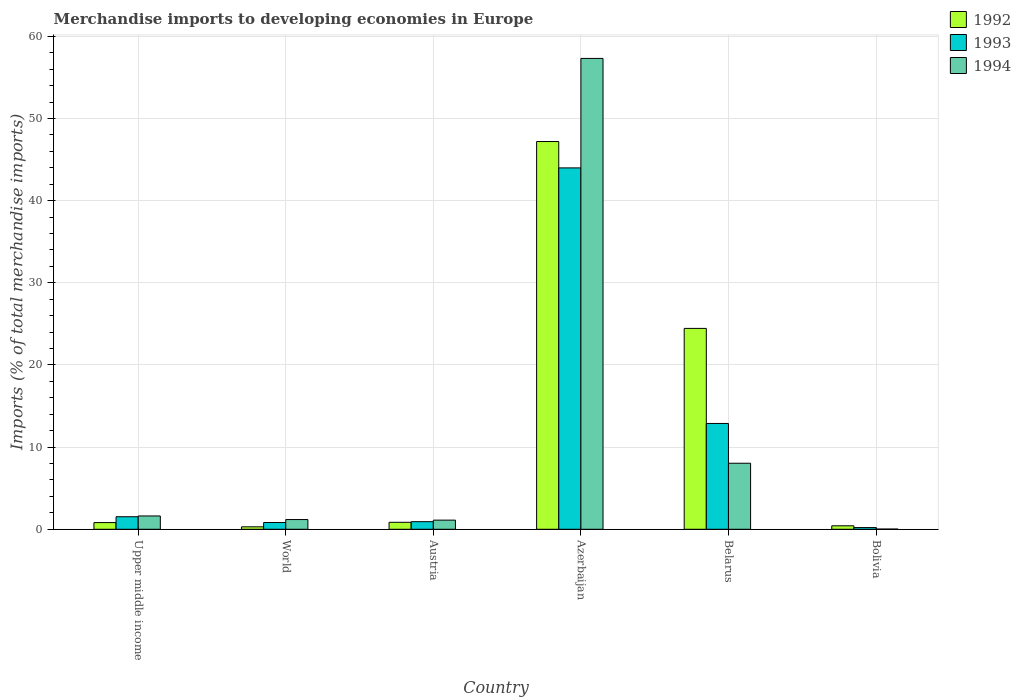How many different coloured bars are there?
Your response must be concise. 3. How many groups of bars are there?
Make the answer very short. 6. Are the number of bars per tick equal to the number of legend labels?
Keep it short and to the point. Yes. How many bars are there on the 6th tick from the left?
Offer a very short reply. 3. How many bars are there on the 1st tick from the right?
Provide a short and direct response. 3. What is the label of the 4th group of bars from the left?
Your response must be concise. Azerbaijan. In how many cases, is the number of bars for a given country not equal to the number of legend labels?
Your answer should be compact. 0. What is the percentage total merchandise imports in 1993 in Austria?
Ensure brevity in your answer.  0.93. Across all countries, what is the maximum percentage total merchandise imports in 1992?
Provide a succinct answer. 47.2. Across all countries, what is the minimum percentage total merchandise imports in 1994?
Make the answer very short. 0.02. In which country was the percentage total merchandise imports in 1993 maximum?
Ensure brevity in your answer.  Azerbaijan. What is the total percentage total merchandise imports in 1994 in the graph?
Your response must be concise. 69.29. What is the difference between the percentage total merchandise imports in 1993 in Austria and that in Belarus?
Keep it short and to the point. -11.95. What is the difference between the percentage total merchandise imports in 1992 in Upper middle income and the percentage total merchandise imports in 1993 in World?
Your answer should be very brief. -0.01. What is the average percentage total merchandise imports in 1994 per country?
Provide a short and direct response. 11.55. What is the difference between the percentage total merchandise imports of/in 1992 and percentage total merchandise imports of/in 1993 in Belarus?
Ensure brevity in your answer.  11.57. In how many countries, is the percentage total merchandise imports in 1993 greater than 58 %?
Offer a very short reply. 0. What is the ratio of the percentage total merchandise imports in 1993 in Belarus to that in World?
Ensure brevity in your answer.  15.63. Is the percentage total merchandise imports in 1993 in Austria less than that in World?
Your answer should be compact. No. Is the difference between the percentage total merchandise imports in 1992 in Azerbaijan and Bolivia greater than the difference between the percentage total merchandise imports in 1993 in Azerbaijan and Bolivia?
Keep it short and to the point. Yes. What is the difference between the highest and the second highest percentage total merchandise imports in 1993?
Give a very brief answer. -42.46. What is the difference between the highest and the lowest percentage total merchandise imports in 1994?
Offer a very short reply. 57.29. Is the sum of the percentage total merchandise imports in 1993 in Austria and Upper middle income greater than the maximum percentage total merchandise imports in 1992 across all countries?
Ensure brevity in your answer.  No. Are all the bars in the graph horizontal?
Give a very brief answer. No. How many countries are there in the graph?
Offer a very short reply. 6. Are the values on the major ticks of Y-axis written in scientific E-notation?
Offer a terse response. No. Where does the legend appear in the graph?
Offer a terse response. Top right. How are the legend labels stacked?
Your answer should be very brief. Vertical. What is the title of the graph?
Keep it short and to the point. Merchandise imports to developing economies in Europe. Does "1993" appear as one of the legend labels in the graph?
Provide a short and direct response. Yes. What is the label or title of the Y-axis?
Your answer should be compact. Imports (% of total merchandise imports). What is the Imports (% of total merchandise imports) of 1992 in Upper middle income?
Make the answer very short. 0.81. What is the Imports (% of total merchandise imports) of 1993 in Upper middle income?
Keep it short and to the point. 1.53. What is the Imports (% of total merchandise imports) of 1994 in Upper middle income?
Keep it short and to the point. 1.62. What is the Imports (% of total merchandise imports) of 1992 in World?
Ensure brevity in your answer.  0.3. What is the Imports (% of total merchandise imports) in 1993 in World?
Provide a succinct answer. 0.82. What is the Imports (% of total merchandise imports) of 1994 in World?
Offer a terse response. 1.18. What is the Imports (% of total merchandise imports) in 1992 in Austria?
Your answer should be very brief. 0.85. What is the Imports (% of total merchandise imports) in 1993 in Austria?
Provide a short and direct response. 0.93. What is the Imports (% of total merchandise imports) in 1994 in Austria?
Keep it short and to the point. 1.11. What is the Imports (% of total merchandise imports) in 1992 in Azerbaijan?
Your answer should be very brief. 47.2. What is the Imports (% of total merchandise imports) of 1993 in Azerbaijan?
Ensure brevity in your answer.  43.99. What is the Imports (% of total merchandise imports) of 1994 in Azerbaijan?
Your answer should be compact. 57.31. What is the Imports (% of total merchandise imports) of 1992 in Belarus?
Offer a very short reply. 24.45. What is the Imports (% of total merchandise imports) in 1993 in Belarus?
Keep it short and to the point. 12.88. What is the Imports (% of total merchandise imports) in 1994 in Belarus?
Keep it short and to the point. 8.04. What is the Imports (% of total merchandise imports) in 1992 in Bolivia?
Provide a succinct answer. 0.42. What is the Imports (% of total merchandise imports) of 1993 in Bolivia?
Give a very brief answer. 0.21. What is the Imports (% of total merchandise imports) of 1994 in Bolivia?
Your answer should be very brief. 0.02. Across all countries, what is the maximum Imports (% of total merchandise imports) in 1992?
Make the answer very short. 47.2. Across all countries, what is the maximum Imports (% of total merchandise imports) in 1993?
Provide a succinct answer. 43.99. Across all countries, what is the maximum Imports (% of total merchandise imports) of 1994?
Your response must be concise. 57.31. Across all countries, what is the minimum Imports (% of total merchandise imports) of 1992?
Keep it short and to the point. 0.3. Across all countries, what is the minimum Imports (% of total merchandise imports) in 1993?
Keep it short and to the point. 0.21. Across all countries, what is the minimum Imports (% of total merchandise imports) of 1994?
Your answer should be compact. 0.02. What is the total Imports (% of total merchandise imports) in 1992 in the graph?
Provide a succinct answer. 74.03. What is the total Imports (% of total merchandise imports) in 1993 in the graph?
Give a very brief answer. 60.35. What is the total Imports (% of total merchandise imports) in 1994 in the graph?
Give a very brief answer. 69.29. What is the difference between the Imports (% of total merchandise imports) in 1992 in Upper middle income and that in World?
Your answer should be compact. 0.52. What is the difference between the Imports (% of total merchandise imports) in 1993 in Upper middle income and that in World?
Your answer should be very brief. 0.7. What is the difference between the Imports (% of total merchandise imports) in 1994 in Upper middle income and that in World?
Keep it short and to the point. 0.44. What is the difference between the Imports (% of total merchandise imports) in 1992 in Upper middle income and that in Austria?
Make the answer very short. -0.03. What is the difference between the Imports (% of total merchandise imports) of 1993 in Upper middle income and that in Austria?
Provide a short and direct response. 0.6. What is the difference between the Imports (% of total merchandise imports) in 1994 in Upper middle income and that in Austria?
Your answer should be very brief. 0.51. What is the difference between the Imports (% of total merchandise imports) in 1992 in Upper middle income and that in Azerbaijan?
Make the answer very short. -46.38. What is the difference between the Imports (% of total merchandise imports) in 1993 in Upper middle income and that in Azerbaijan?
Provide a short and direct response. -42.46. What is the difference between the Imports (% of total merchandise imports) in 1994 in Upper middle income and that in Azerbaijan?
Ensure brevity in your answer.  -55.69. What is the difference between the Imports (% of total merchandise imports) of 1992 in Upper middle income and that in Belarus?
Offer a very short reply. -23.64. What is the difference between the Imports (% of total merchandise imports) of 1993 in Upper middle income and that in Belarus?
Offer a terse response. -11.35. What is the difference between the Imports (% of total merchandise imports) in 1994 in Upper middle income and that in Belarus?
Your response must be concise. -6.42. What is the difference between the Imports (% of total merchandise imports) of 1992 in Upper middle income and that in Bolivia?
Offer a very short reply. 0.39. What is the difference between the Imports (% of total merchandise imports) in 1993 in Upper middle income and that in Bolivia?
Provide a short and direct response. 1.32. What is the difference between the Imports (% of total merchandise imports) in 1994 in Upper middle income and that in Bolivia?
Provide a short and direct response. 1.6. What is the difference between the Imports (% of total merchandise imports) in 1992 in World and that in Austria?
Your answer should be compact. -0.55. What is the difference between the Imports (% of total merchandise imports) in 1993 in World and that in Austria?
Your answer should be compact. -0.1. What is the difference between the Imports (% of total merchandise imports) of 1994 in World and that in Austria?
Offer a very short reply. 0.07. What is the difference between the Imports (% of total merchandise imports) in 1992 in World and that in Azerbaijan?
Offer a very short reply. -46.9. What is the difference between the Imports (% of total merchandise imports) in 1993 in World and that in Azerbaijan?
Your answer should be compact. -43.16. What is the difference between the Imports (% of total merchandise imports) in 1994 in World and that in Azerbaijan?
Ensure brevity in your answer.  -56.13. What is the difference between the Imports (% of total merchandise imports) in 1992 in World and that in Belarus?
Offer a very short reply. -24.15. What is the difference between the Imports (% of total merchandise imports) of 1993 in World and that in Belarus?
Ensure brevity in your answer.  -12.06. What is the difference between the Imports (% of total merchandise imports) in 1994 in World and that in Belarus?
Provide a succinct answer. -6.85. What is the difference between the Imports (% of total merchandise imports) of 1992 in World and that in Bolivia?
Your answer should be very brief. -0.12. What is the difference between the Imports (% of total merchandise imports) in 1993 in World and that in Bolivia?
Make the answer very short. 0.62. What is the difference between the Imports (% of total merchandise imports) in 1994 in World and that in Bolivia?
Keep it short and to the point. 1.16. What is the difference between the Imports (% of total merchandise imports) of 1992 in Austria and that in Azerbaijan?
Your answer should be very brief. -46.35. What is the difference between the Imports (% of total merchandise imports) in 1993 in Austria and that in Azerbaijan?
Offer a terse response. -43.06. What is the difference between the Imports (% of total merchandise imports) of 1994 in Austria and that in Azerbaijan?
Provide a short and direct response. -56.2. What is the difference between the Imports (% of total merchandise imports) of 1992 in Austria and that in Belarus?
Ensure brevity in your answer.  -23.6. What is the difference between the Imports (% of total merchandise imports) of 1993 in Austria and that in Belarus?
Ensure brevity in your answer.  -11.95. What is the difference between the Imports (% of total merchandise imports) in 1994 in Austria and that in Belarus?
Your response must be concise. -6.92. What is the difference between the Imports (% of total merchandise imports) in 1992 in Austria and that in Bolivia?
Offer a terse response. 0.43. What is the difference between the Imports (% of total merchandise imports) in 1993 in Austria and that in Bolivia?
Keep it short and to the point. 0.72. What is the difference between the Imports (% of total merchandise imports) in 1994 in Austria and that in Bolivia?
Provide a short and direct response. 1.09. What is the difference between the Imports (% of total merchandise imports) in 1992 in Azerbaijan and that in Belarus?
Your answer should be very brief. 22.75. What is the difference between the Imports (% of total merchandise imports) in 1993 in Azerbaijan and that in Belarus?
Give a very brief answer. 31.11. What is the difference between the Imports (% of total merchandise imports) in 1994 in Azerbaijan and that in Belarus?
Your response must be concise. 49.28. What is the difference between the Imports (% of total merchandise imports) in 1992 in Azerbaijan and that in Bolivia?
Your response must be concise. 46.78. What is the difference between the Imports (% of total merchandise imports) of 1993 in Azerbaijan and that in Bolivia?
Provide a succinct answer. 43.78. What is the difference between the Imports (% of total merchandise imports) of 1994 in Azerbaijan and that in Bolivia?
Give a very brief answer. 57.29. What is the difference between the Imports (% of total merchandise imports) of 1992 in Belarus and that in Bolivia?
Provide a short and direct response. 24.03. What is the difference between the Imports (% of total merchandise imports) of 1993 in Belarus and that in Bolivia?
Make the answer very short. 12.67. What is the difference between the Imports (% of total merchandise imports) in 1994 in Belarus and that in Bolivia?
Give a very brief answer. 8.01. What is the difference between the Imports (% of total merchandise imports) of 1992 in Upper middle income and the Imports (% of total merchandise imports) of 1993 in World?
Make the answer very short. -0.01. What is the difference between the Imports (% of total merchandise imports) in 1992 in Upper middle income and the Imports (% of total merchandise imports) in 1994 in World?
Offer a terse response. -0.37. What is the difference between the Imports (% of total merchandise imports) in 1993 in Upper middle income and the Imports (% of total merchandise imports) in 1994 in World?
Offer a very short reply. 0.34. What is the difference between the Imports (% of total merchandise imports) in 1992 in Upper middle income and the Imports (% of total merchandise imports) in 1993 in Austria?
Your answer should be compact. -0.11. What is the difference between the Imports (% of total merchandise imports) of 1992 in Upper middle income and the Imports (% of total merchandise imports) of 1994 in Austria?
Provide a succinct answer. -0.3. What is the difference between the Imports (% of total merchandise imports) in 1993 in Upper middle income and the Imports (% of total merchandise imports) in 1994 in Austria?
Provide a succinct answer. 0.41. What is the difference between the Imports (% of total merchandise imports) in 1992 in Upper middle income and the Imports (% of total merchandise imports) in 1993 in Azerbaijan?
Ensure brevity in your answer.  -43.17. What is the difference between the Imports (% of total merchandise imports) in 1992 in Upper middle income and the Imports (% of total merchandise imports) in 1994 in Azerbaijan?
Keep it short and to the point. -56.5. What is the difference between the Imports (% of total merchandise imports) of 1993 in Upper middle income and the Imports (% of total merchandise imports) of 1994 in Azerbaijan?
Offer a terse response. -55.79. What is the difference between the Imports (% of total merchandise imports) in 1992 in Upper middle income and the Imports (% of total merchandise imports) in 1993 in Belarus?
Ensure brevity in your answer.  -12.07. What is the difference between the Imports (% of total merchandise imports) in 1992 in Upper middle income and the Imports (% of total merchandise imports) in 1994 in Belarus?
Offer a very short reply. -7.22. What is the difference between the Imports (% of total merchandise imports) in 1993 in Upper middle income and the Imports (% of total merchandise imports) in 1994 in Belarus?
Your response must be concise. -6.51. What is the difference between the Imports (% of total merchandise imports) of 1992 in Upper middle income and the Imports (% of total merchandise imports) of 1993 in Bolivia?
Make the answer very short. 0.61. What is the difference between the Imports (% of total merchandise imports) in 1992 in Upper middle income and the Imports (% of total merchandise imports) in 1994 in Bolivia?
Provide a succinct answer. 0.79. What is the difference between the Imports (% of total merchandise imports) in 1993 in Upper middle income and the Imports (% of total merchandise imports) in 1994 in Bolivia?
Your answer should be compact. 1.5. What is the difference between the Imports (% of total merchandise imports) in 1992 in World and the Imports (% of total merchandise imports) in 1993 in Austria?
Ensure brevity in your answer.  -0.63. What is the difference between the Imports (% of total merchandise imports) of 1992 in World and the Imports (% of total merchandise imports) of 1994 in Austria?
Ensure brevity in your answer.  -0.81. What is the difference between the Imports (% of total merchandise imports) of 1993 in World and the Imports (% of total merchandise imports) of 1994 in Austria?
Make the answer very short. -0.29. What is the difference between the Imports (% of total merchandise imports) of 1992 in World and the Imports (% of total merchandise imports) of 1993 in Azerbaijan?
Your answer should be very brief. -43.69. What is the difference between the Imports (% of total merchandise imports) of 1992 in World and the Imports (% of total merchandise imports) of 1994 in Azerbaijan?
Offer a very short reply. -57.01. What is the difference between the Imports (% of total merchandise imports) in 1993 in World and the Imports (% of total merchandise imports) in 1994 in Azerbaijan?
Your response must be concise. -56.49. What is the difference between the Imports (% of total merchandise imports) of 1992 in World and the Imports (% of total merchandise imports) of 1993 in Belarus?
Provide a succinct answer. -12.58. What is the difference between the Imports (% of total merchandise imports) of 1992 in World and the Imports (% of total merchandise imports) of 1994 in Belarus?
Keep it short and to the point. -7.74. What is the difference between the Imports (% of total merchandise imports) of 1993 in World and the Imports (% of total merchandise imports) of 1994 in Belarus?
Give a very brief answer. -7.21. What is the difference between the Imports (% of total merchandise imports) in 1992 in World and the Imports (% of total merchandise imports) in 1993 in Bolivia?
Offer a very short reply. 0.09. What is the difference between the Imports (% of total merchandise imports) of 1992 in World and the Imports (% of total merchandise imports) of 1994 in Bolivia?
Your answer should be compact. 0.27. What is the difference between the Imports (% of total merchandise imports) in 1993 in World and the Imports (% of total merchandise imports) in 1994 in Bolivia?
Ensure brevity in your answer.  0.8. What is the difference between the Imports (% of total merchandise imports) in 1992 in Austria and the Imports (% of total merchandise imports) in 1993 in Azerbaijan?
Make the answer very short. -43.14. What is the difference between the Imports (% of total merchandise imports) in 1992 in Austria and the Imports (% of total merchandise imports) in 1994 in Azerbaijan?
Offer a terse response. -56.46. What is the difference between the Imports (% of total merchandise imports) in 1993 in Austria and the Imports (% of total merchandise imports) in 1994 in Azerbaijan?
Ensure brevity in your answer.  -56.39. What is the difference between the Imports (% of total merchandise imports) of 1992 in Austria and the Imports (% of total merchandise imports) of 1993 in Belarus?
Keep it short and to the point. -12.03. What is the difference between the Imports (% of total merchandise imports) of 1992 in Austria and the Imports (% of total merchandise imports) of 1994 in Belarus?
Offer a terse response. -7.19. What is the difference between the Imports (% of total merchandise imports) of 1993 in Austria and the Imports (% of total merchandise imports) of 1994 in Belarus?
Your response must be concise. -7.11. What is the difference between the Imports (% of total merchandise imports) in 1992 in Austria and the Imports (% of total merchandise imports) in 1993 in Bolivia?
Provide a short and direct response. 0.64. What is the difference between the Imports (% of total merchandise imports) in 1992 in Austria and the Imports (% of total merchandise imports) in 1994 in Bolivia?
Your answer should be compact. 0.82. What is the difference between the Imports (% of total merchandise imports) of 1993 in Austria and the Imports (% of total merchandise imports) of 1994 in Bolivia?
Ensure brevity in your answer.  0.9. What is the difference between the Imports (% of total merchandise imports) of 1992 in Azerbaijan and the Imports (% of total merchandise imports) of 1993 in Belarus?
Offer a very short reply. 34.32. What is the difference between the Imports (% of total merchandise imports) of 1992 in Azerbaijan and the Imports (% of total merchandise imports) of 1994 in Belarus?
Your response must be concise. 39.16. What is the difference between the Imports (% of total merchandise imports) in 1993 in Azerbaijan and the Imports (% of total merchandise imports) in 1994 in Belarus?
Give a very brief answer. 35.95. What is the difference between the Imports (% of total merchandise imports) of 1992 in Azerbaijan and the Imports (% of total merchandise imports) of 1993 in Bolivia?
Keep it short and to the point. 46.99. What is the difference between the Imports (% of total merchandise imports) of 1992 in Azerbaijan and the Imports (% of total merchandise imports) of 1994 in Bolivia?
Provide a succinct answer. 47.17. What is the difference between the Imports (% of total merchandise imports) of 1993 in Azerbaijan and the Imports (% of total merchandise imports) of 1994 in Bolivia?
Keep it short and to the point. 43.96. What is the difference between the Imports (% of total merchandise imports) of 1992 in Belarus and the Imports (% of total merchandise imports) of 1993 in Bolivia?
Provide a short and direct response. 24.24. What is the difference between the Imports (% of total merchandise imports) in 1992 in Belarus and the Imports (% of total merchandise imports) in 1994 in Bolivia?
Your response must be concise. 24.43. What is the difference between the Imports (% of total merchandise imports) in 1993 in Belarus and the Imports (% of total merchandise imports) in 1994 in Bolivia?
Provide a short and direct response. 12.86. What is the average Imports (% of total merchandise imports) in 1992 per country?
Your response must be concise. 12.34. What is the average Imports (% of total merchandise imports) of 1993 per country?
Your answer should be very brief. 10.06. What is the average Imports (% of total merchandise imports) of 1994 per country?
Keep it short and to the point. 11.55. What is the difference between the Imports (% of total merchandise imports) in 1992 and Imports (% of total merchandise imports) in 1993 in Upper middle income?
Ensure brevity in your answer.  -0.71. What is the difference between the Imports (% of total merchandise imports) of 1992 and Imports (% of total merchandise imports) of 1994 in Upper middle income?
Give a very brief answer. -0.81. What is the difference between the Imports (% of total merchandise imports) of 1993 and Imports (% of total merchandise imports) of 1994 in Upper middle income?
Provide a short and direct response. -0.1. What is the difference between the Imports (% of total merchandise imports) of 1992 and Imports (% of total merchandise imports) of 1993 in World?
Make the answer very short. -0.52. What is the difference between the Imports (% of total merchandise imports) in 1992 and Imports (% of total merchandise imports) in 1994 in World?
Offer a terse response. -0.88. What is the difference between the Imports (% of total merchandise imports) of 1993 and Imports (% of total merchandise imports) of 1994 in World?
Offer a very short reply. -0.36. What is the difference between the Imports (% of total merchandise imports) in 1992 and Imports (% of total merchandise imports) in 1993 in Austria?
Provide a short and direct response. -0.08. What is the difference between the Imports (% of total merchandise imports) in 1992 and Imports (% of total merchandise imports) in 1994 in Austria?
Provide a short and direct response. -0.26. What is the difference between the Imports (% of total merchandise imports) in 1993 and Imports (% of total merchandise imports) in 1994 in Austria?
Give a very brief answer. -0.19. What is the difference between the Imports (% of total merchandise imports) in 1992 and Imports (% of total merchandise imports) in 1993 in Azerbaijan?
Offer a terse response. 3.21. What is the difference between the Imports (% of total merchandise imports) of 1992 and Imports (% of total merchandise imports) of 1994 in Azerbaijan?
Provide a short and direct response. -10.11. What is the difference between the Imports (% of total merchandise imports) of 1993 and Imports (% of total merchandise imports) of 1994 in Azerbaijan?
Your answer should be very brief. -13.33. What is the difference between the Imports (% of total merchandise imports) of 1992 and Imports (% of total merchandise imports) of 1993 in Belarus?
Ensure brevity in your answer.  11.57. What is the difference between the Imports (% of total merchandise imports) in 1992 and Imports (% of total merchandise imports) in 1994 in Belarus?
Offer a terse response. 16.41. What is the difference between the Imports (% of total merchandise imports) in 1993 and Imports (% of total merchandise imports) in 1994 in Belarus?
Give a very brief answer. 4.84. What is the difference between the Imports (% of total merchandise imports) of 1992 and Imports (% of total merchandise imports) of 1993 in Bolivia?
Your answer should be compact. 0.22. What is the difference between the Imports (% of total merchandise imports) of 1992 and Imports (% of total merchandise imports) of 1994 in Bolivia?
Provide a succinct answer. 0.4. What is the difference between the Imports (% of total merchandise imports) in 1993 and Imports (% of total merchandise imports) in 1994 in Bolivia?
Provide a short and direct response. 0.18. What is the ratio of the Imports (% of total merchandise imports) of 1992 in Upper middle income to that in World?
Make the answer very short. 2.72. What is the ratio of the Imports (% of total merchandise imports) of 1993 in Upper middle income to that in World?
Ensure brevity in your answer.  1.85. What is the ratio of the Imports (% of total merchandise imports) of 1994 in Upper middle income to that in World?
Give a very brief answer. 1.37. What is the ratio of the Imports (% of total merchandise imports) of 1992 in Upper middle income to that in Austria?
Provide a succinct answer. 0.96. What is the ratio of the Imports (% of total merchandise imports) of 1993 in Upper middle income to that in Austria?
Your answer should be very brief. 1.65. What is the ratio of the Imports (% of total merchandise imports) of 1994 in Upper middle income to that in Austria?
Give a very brief answer. 1.46. What is the ratio of the Imports (% of total merchandise imports) in 1992 in Upper middle income to that in Azerbaijan?
Your answer should be very brief. 0.02. What is the ratio of the Imports (% of total merchandise imports) in 1993 in Upper middle income to that in Azerbaijan?
Give a very brief answer. 0.03. What is the ratio of the Imports (% of total merchandise imports) of 1994 in Upper middle income to that in Azerbaijan?
Offer a very short reply. 0.03. What is the ratio of the Imports (% of total merchandise imports) in 1993 in Upper middle income to that in Belarus?
Your answer should be compact. 0.12. What is the ratio of the Imports (% of total merchandise imports) in 1994 in Upper middle income to that in Belarus?
Your answer should be compact. 0.2. What is the ratio of the Imports (% of total merchandise imports) in 1992 in Upper middle income to that in Bolivia?
Your answer should be very brief. 1.93. What is the ratio of the Imports (% of total merchandise imports) in 1993 in Upper middle income to that in Bolivia?
Your response must be concise. 7.36. What is the ratio of the Imports (% of total merchandise imports) of 1994 in Upper middle income to that in Bolivia?
Ensure brevity in your answer.  65.76. What is the ratio of the Imports (% of total merchandise imports) in 1992 in World to that in Austria?
Offer a very short reply. 0.35. What is the ratio of the Imports (% of total merchandise imports) in 1993 in World to that in Austria?
Provide a short and direct response. 0.89. What is the ratio of the Imports (% of total merchandise imports) of 1994 in World to that in Austria?
Provide a short and direct response. 1.06. What is the ratio of the Imports (% of total merchandise imports) of 1992 in World to that in Azerbaijan?
Your answer should be very brief. 0.01. What is the ratio of the Imports (% of total merchandise imports) in 1993 in World to that in Azerbaijan?
Your answer should be compact. 0.02. What is the ratio of the Imports (% of total merchandise imports) in 1994 in World to that in Azerbaijan?
Make the answer very short. 0.02. What is the ratio of the Imports (% of total merchandise imports) of 1992 in World to that in Belarus?
Provide a succinct answer. 0.01. What is the ratio of the Imports (% of total merchandise imports) in 1993 in World to that in Belarus?
Provide a succinct answer. 0.06. What is the ratio of the Imports (% of total merchandise imports) in 1994 in World to that in Belarus?
Ensure brevity in your answer.  0.15. What is the ratio of the Imports (% of total merchandise imports) in 1992 in World to that in Bolivia?
Your answer should be compact. 0.71. What is the ratio of the Imports (% of total merchandise imports) of 1993 in World to that in Bolivia?
Offer a very short reply. 3.97. What is the ratio of the Imports (% of total merchandise imports) in 1994 in World to that in Bolivia?
Your answer should be compact. 47.97. What is the ratio of the Imports (% of total merchandise imports) of 1992 in Austria to that in Azerbaijan?
Keep it short and to the point. 0.02. What is the ratio of the Imports (% of total merchandise imports) in 1993 in Austria to that in Azerbaijan?
Your response must be concise. 0.02. What is the ratio of the Imports (% of total merchandise imports) of 1994 in Austria to that in Azerbaijan?
Offer a terse response. 0.02. What is the ratio of the Imports (% of total merchandise imports) of 1992 in Austria to that in Belarus?
Ensure brevity in your answer.  0.03. What is the ratio of the Imports (% of total merchandise imports) of 1993 in Austria to that in Belarus?
Your answer should be very brief. 0.07. What is the ratio of the Imports (% of total merchandise imports) of 1994 in Austria to that in Belarus?
Provide a succinct answer. 0.14. What is the ratio of the Imports (% of total merchandise imports) of 1992 in Austria to that in Bolivia?
Keep it short and to the point. 2.01. What is the ratio of the Imports (% of total merchandise imports) of 1993 in Austria to that in Bolivia?
Offer a terse response. 4.46. What is the ratio of the Imports (% of total merchandise imports) in 1994 in Austria to that in Bolivia?
Make the answer very short. 45.14. What is the ratio of the Imports (% of total merchandise imports) of 1992 in Azerbaijan to that in Belarus?
Offer a very short reply. 1.93. What is the ratio of the Imports (% of total merchandise imports) of 1993 in Azerbaijan to that in Belarus?
Provide a succinct answer. 3.42. What is the ratio of the Imports (% of total merchandise imports) in 1994 in Azerbaijan to that in Belarus?
Offer a very short reply. 7.13. What is the ratio of the Imports (% of total merchandise imports) of 1992 in Azerbaijan to that in Bolivia?
Provide a succinct answer. 111.66. What is the ratio of the Imports (% of total merchandise imports) in 1993 in Azerbaijan to that in Bolivia?
Provide a short and direct response. 212.06. What is the ratio of the Imports (% of total merchandise imports) in 1994 in Azerbaijan to that in Bolivia?
Ensure brevity in your answer.  2324.83. What is the ratio of the Imports (% of total merchandise imports) of 1992 in Belarus to that in Bolivia?
Ensure brevity in your answer.  57.84. What is the ratio of the Imports (% of total merchandise imports) of 1993 in Belarus to that in Bolivia?
Your answer should be very brief. 62.09. What is the ratio of the Imports (% of total merchandise imports) in 1994 in Belarus to that in Bolivia?
Your answer should be compact. 326.01. What is the difference between the highest and the second highest Imports (% of total merchandise imports) of 1992?
Provide a short and direct response. 22.75. What is the difference between the highest and the second highest Imports (% of total merchandise imports) of 1993?
Provide a short and direct response. 31.11. What is the difference between the highest and the second highest Imports (% of total merchandise imports) of 1994?
Provide a short and direct response. 49.28. What is the difference between the highest and the lowest Imports (% of total merchandise imports) of 1992?
Give a very brief answer. 46.9. What is the difference between the highest and the lowest Imports (% of total merchandise imports) in 1993?
Ensure brevity in your answer.  43.78. What is the difference between the highest and the lowest Imports (% of total merchandise imports) of 1994?
Make the answer very short. 57.29. 